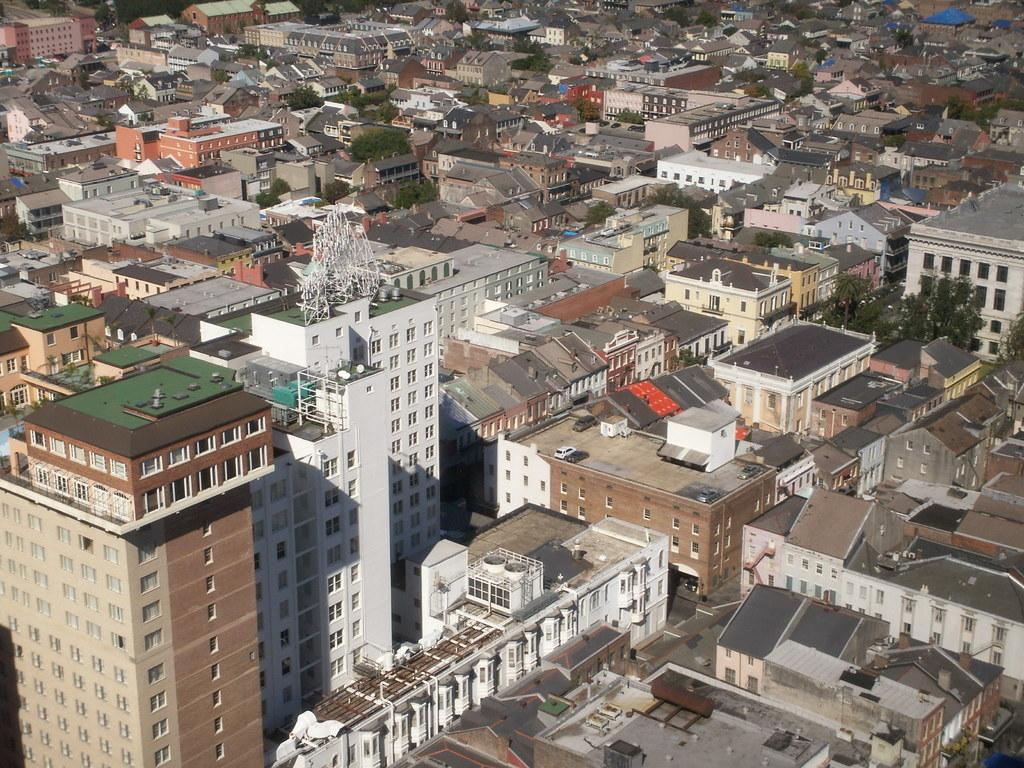What type of structures are located at the bottom of the picture? There are buildings and cement poles at the bottom of the picture. What can be seen in the background of the image? There are buildings, cars, and trees in the background of the image. Where was the image taken? The image was clicked outside the city. What type of creature is flying with a birthday hat in the image? There is no creature or birthday hat present in the image. How many wings does the car in the background have? The image does not show any wings, as it features cars and not creatures with wings. 